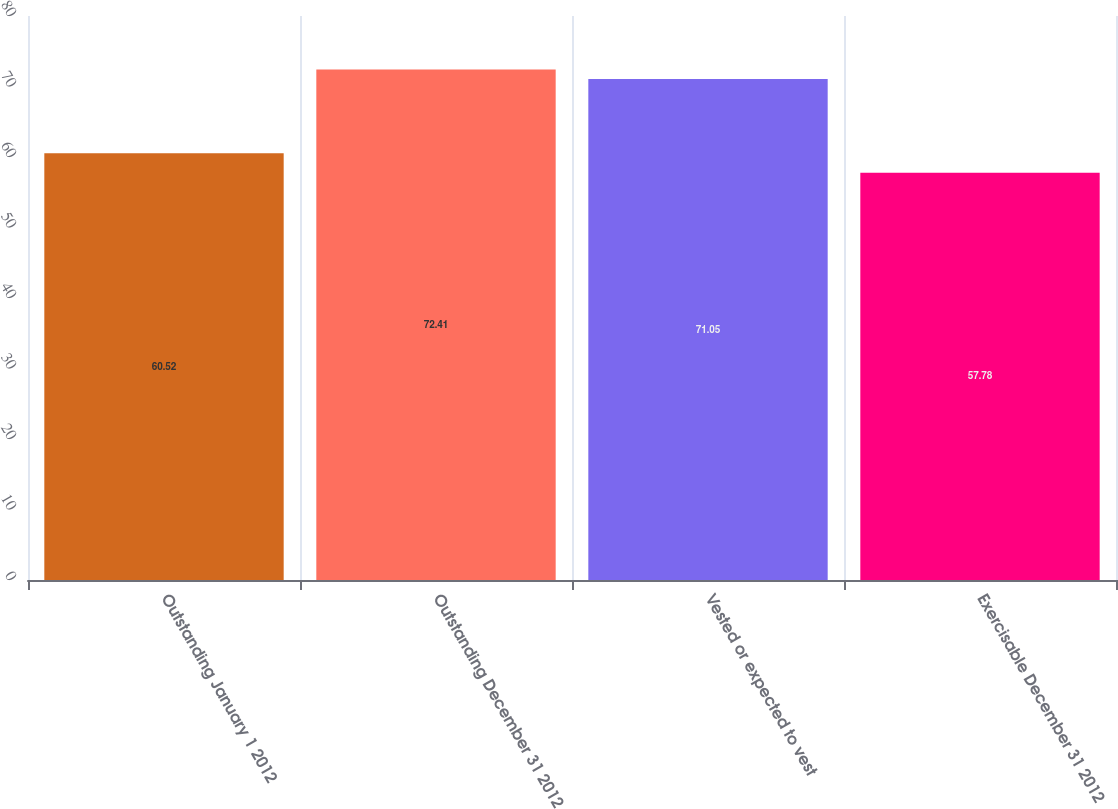Convert chart to OTSL. <chart><loc_0><loc_0><loc_500><loc_500><bar_chart><fcel>Outstanding January 1 2012<fcel>Outstanding December 31 2012<fcel>Vested or expected to vest<fcel>Exercisable December 31 2012<nl><fcel>60.52<fcel>72.41<fcel>71.05<fcel>57.78<nl></chart> 